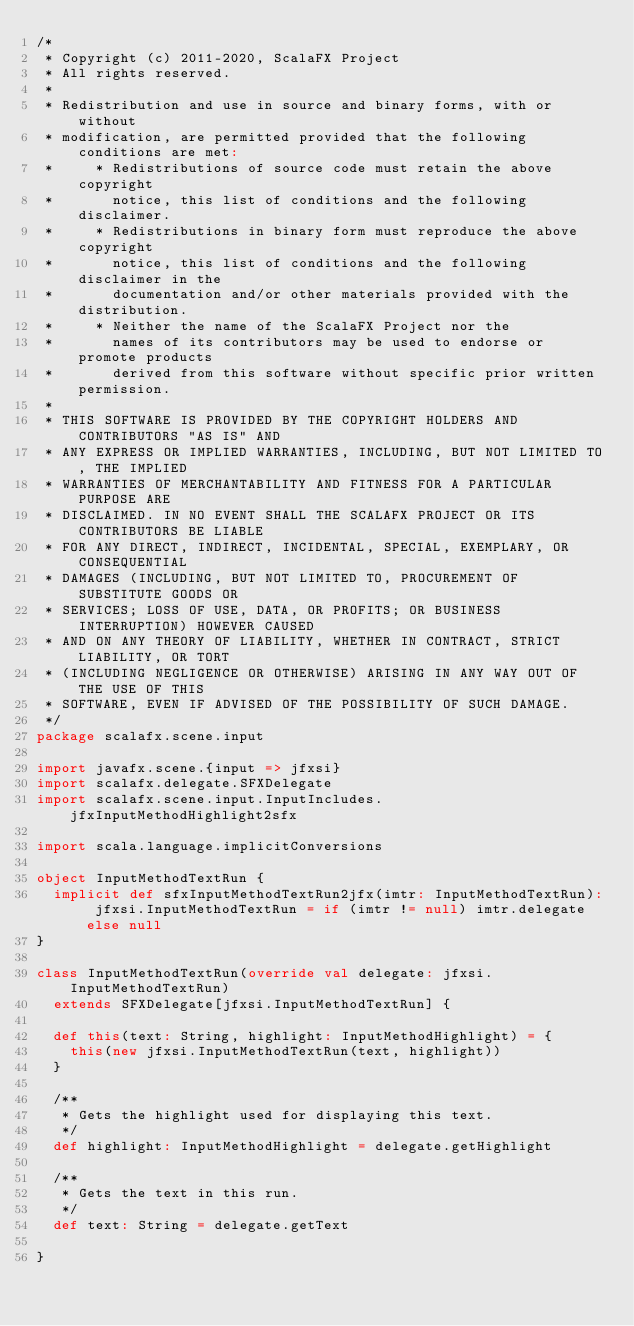Convert code to text. <code><loc_0><loc_0><loc_500><loc_500><_Scala_>/*
 * Copyright (c) 2011-2020, ScalaFX Project
 * All rights reserved.
 *
 * Redistribution and use in source and binary forms, with or without
 * modification, are permitted provided that the following conditions are met:
 *     * Redistributions of source code must retain the above copyright
 *       notice, this list of conditions and the following disclaimer.
 *     * Redistributions in binary form must reproduce the above copyright
 *       notice, this list of conditions and the following disclaimer in the
 *       documentation and/or other materials provided with the distribution.
 *     * Neither the name of the ScalaFX Project nor the
 *       names of its contributors may be used to endorse or promote products
 *       derived from this software without specific prior written permission.
 *
 * THIS SOFTWARE IS PROVIDED BY THE COPYRIGHT HOLDERS AND CONTRIBUTORS "AS IS" AND
 * ANY EXPRESS OR IMPLIED WARRANTIES, INCLUDING, BUT NOT LIMITED TO, THE IMPLIED
 * WARRANTIES OF MERCHANTABILITY AND FITNESS FOR A PARTICULAR PURPOSE ARE
 * DISCLAIMED. IN NO EVENT SHALL THE SCALAFX PROJECT OR ITS CONTRIBUTORS BE LIABLE
 * FOR ANY DIRECT, INDIRECT, INCIDENTAL, SPECIAL, EXEMPLARY, OR CONSEQUENTIAL
 * DAMAGES (INCLUDING, BUT NOT LIMITED TO, PROCUREMENT OF SUBSTITUTE GOODS OR
 * SERVICES; LOSS OF USE, DATA, OR PROFITS; OR BUSINESS INTERRUPTION) HOWEVER CAUSED
 * AND ON ANY THEORY OF LIABILITY, WHETHER IN CONTRACT, STRICT LIABILITY, OR TORT
 * (INCLUDING NEGLIGENCE OR OTHERWISE) ARISING IN ANY WAY OUT OF THE USE OF THIS
 * SOFTWARE, EVEN IF ADVISED OF THE POSSIBILITY OF SUCH DAMAGE.
 */
package scalafx.scene.input

import javafx.scene.{input => jfxsi}
import scalafx.delegate.SFXDelegate
import scalafx.scene.input.InputIncludes.jfxInputMethodHighlight2sfx

import scala.language.implicitConversions

object InputMethodTextRun {
  implicit def sfxInputMethodTextRun2jfx(imtr: InputMethodTextRun): jfxsi.InputMethodTextRun = if (imtr != null) imtr.delegate else null
}

class InputMethodTextRun(override val delegate: jfxsi.InputMethodTextRun)
  extends SFXDelegate[jfxsi.InputMethodTextRun] {

  def this(text: String, highlight: InputMethodHighlight) = {
    this(new jfxsi.InputMethodTextRun(text, highlight))
  }

  /**
   * Gets the highlight used for displaying this text.
   */
  def highlight: InputMethodHighlight = delegate.getHighlight

  /**
   * Gets the text in this run.
   */
  def text: String = delegate.getText

}</code> 